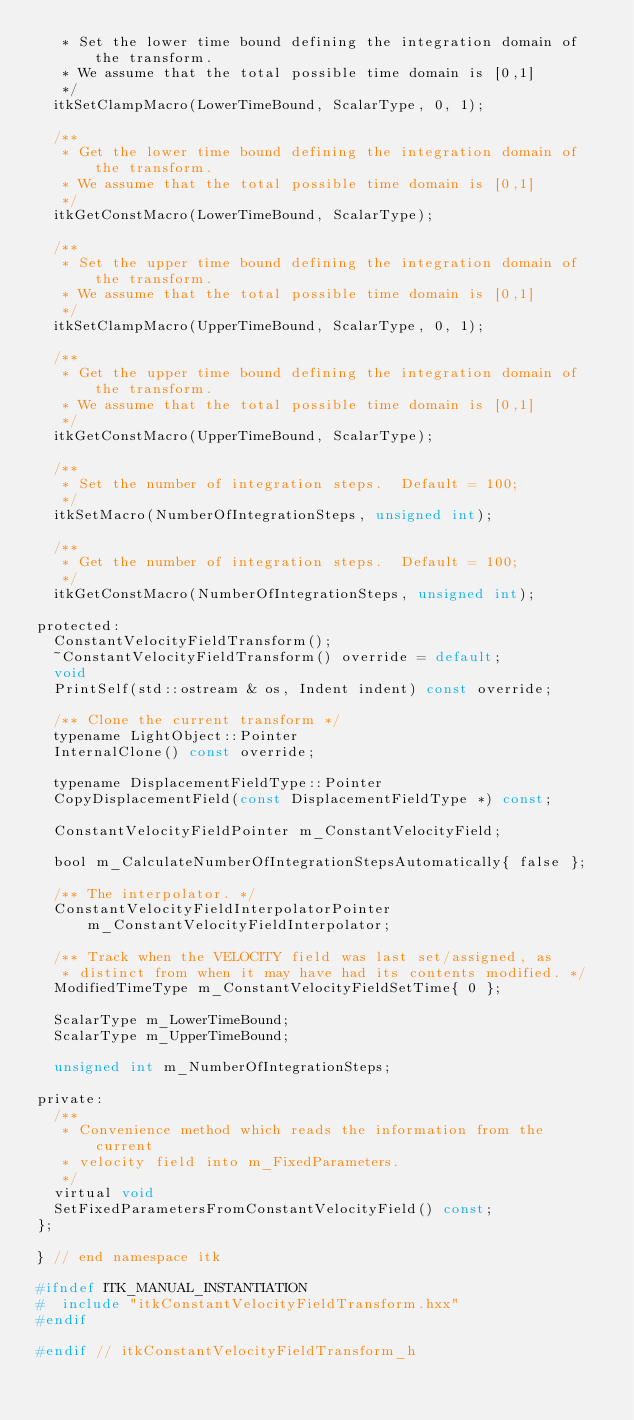Convert code to text. <code><loc_0><loc_0><loc_500><loc_500><_C_>   * Set the lower time bound defining the integration domain of the transform.
   * We assume that the total possible time domain is [0,1]
   */
  itkSetClampMacro(LowerTimeBound, ScalarType, 0, 1);

  /**
   * Get the lower time bound defining the integration domain of the transform.
   * We assume that the total possible time domain is [0,1]
   */
  itkGetConstMacro(LowerTimeBound, ScalarType);

  /**
   * Set the upper time bound defining the integration domain of the transform.
   * We assume that the total possible time domain is [0,1]
   */
  itkSetClampMacro(UpperTimeBound, ScalarType, 0, 1);

  /**
   * Get the upper time bound defining the integration domain of the transform.
   * We assume that the total possible time domain is [0,1]
   */
  itkGetConstMacro(UpperTimeBound, ScalarType);

  /**
   * Set the number of integration steps.  Default = 100;
   */
  itkSetMacro(NumberOfIntegrationSteps, unsigned int);

  /**
   * Get the number of integration steps.  Default = 100;
   */
  itkGetConstMacro(NumberOfIntegrationSteps, unsigned int);

protected:
  ConstantVelocityFieldTransform();
  ~ConstantVelocityFieldTransform() override = default;
  void
  PrintSelf(std::ostream & os, Indent indent) const override;

  /** Clone the current transform */
  typename LightObject::Pointer
  InternalClone() const override;

  typename DisplacementFieldType::Pointer
  CopyDisplacementField(const DisplacementFieldType *) const;

  ConstantVelocityFieldPointer m_ConstantVelocityField;

  bool m_CalculateNumberOfIntegrationStepsAutomatically{ false };

  /** The interpolator. */
  ConstantVelocityFieldInterpolatorPointer m_ConstantVelocityFieldInterpolator;

  /** Track when the VELOCITY field was last set/assigned, as
   * distinct from when it may have had its contents modified. */
  ModifiedTimeType m_ConstantVelocityFieldSetTime{ 0 };

  ScalarType m_LowerTimeBound;
  ScalarType m_UpperTimeBound;

  unsigned int m_NumberOfIntegrationSteps;

private:
  /**
   * Convenience method which reads the information from the current
   * velocity field into m_FixedParameters.
   */
  virtual void
  SetFixedParametersFromConstantVelocityField() const;
};

} // end namespace itk

#ifndef ITK_MANUAL_INSTANTIATION
#  include "itkConstantVelocityFieldTransform.hxx"
#endif

#endif // itkConstantVelocityFieldTransform_h
</code> 